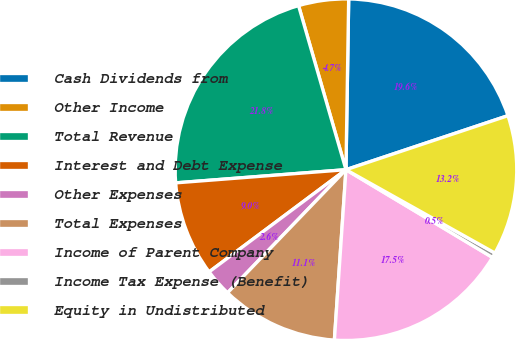Convert chart. <chart><loc_0><loc_0><loc_500><loc_500><pie_chart><fcel>Cash Dividends from<fcel>Other Income<fcel>Total Revenue<fcel>Interest and Debt Expense<fcel>Other Expenses<fcel>Total Expenses<fcel>Income of Parent Company<fcel>Income Tax Expense (Benefit)<fcel>Equity in Undistributed<nl><fcel>19.62%<fcel>4.73%<fcel>21.75%<fcel>8.98%<fcel>2.6%<fcel>11.11%<fcel>17.49%<fcel>0.47%<fcel>13.24%<nl></chart> 